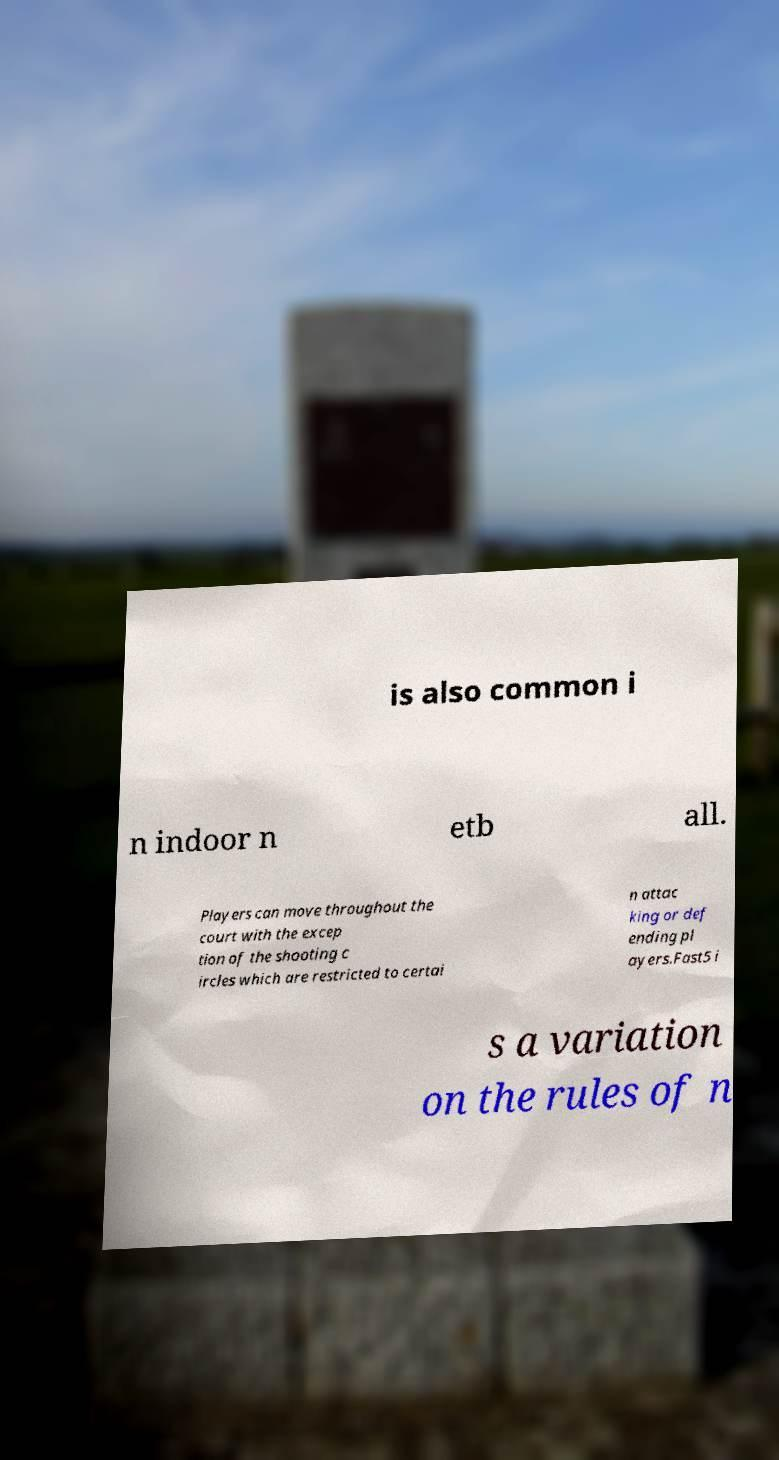There's text embedded in this image that I need extracted. Can you transcribe it verbatim? is also common i n indoor n etb all. Players can move throughout the court with the excep tion of the shooting c ircles which are restricted to certai n attac king or def ending pl ayers.Fast5 i s a variation on the rules of n 